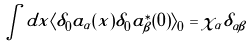Convert formula to latex. <formula><loc_0><loc_0><loc_500><loc_500>\int d x \langle \delta _ { 0 } a _ { \alpha } ( x ) \delta _ { 0 } a _ { \beta } ^ { \ast } ( 0 ) \rangle _ { 0 } = \chi _ { \alpha } \delta _ { \alpha \beta }</formula> 